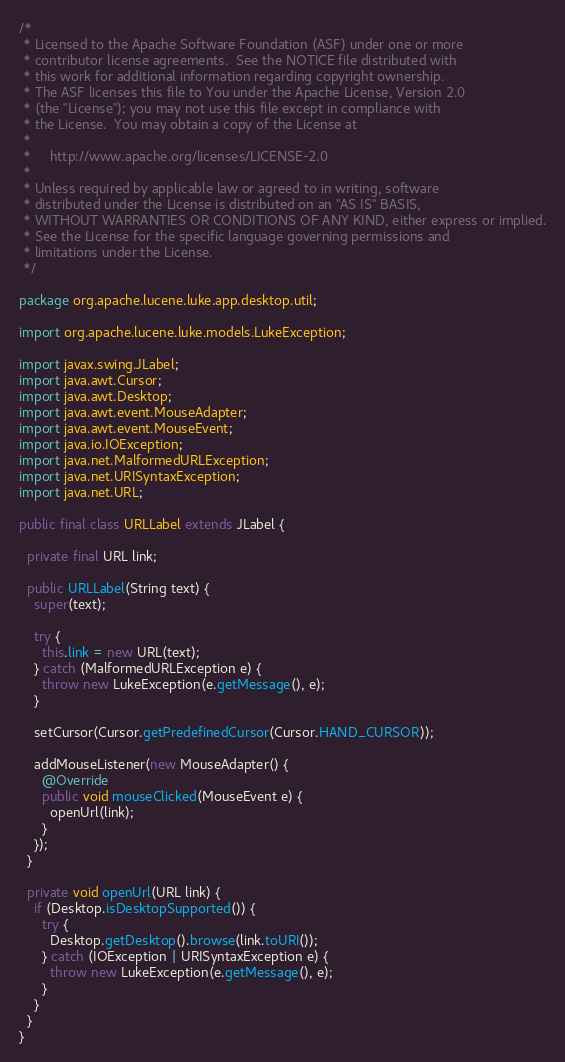<code> <loc_0><loc_0><loc_500><loc_500><_Java_>/*
 * Licensed to the Apache Software Foundation (ASF) under one or more
 * contributor license agreements.  See the NOTICE file distributed with
 * this work for additional information regarding copyright ownership.
 * The ASF licenses this file to You under the Apache License, Version 2.0
 * (the "License"); you may not use this file except in compliance with
 * the License.  You may obtain a copy of the License at
 *
 *     http://www.apache.org/licenses/LICENSE-2.0
 *
 * Unless required by applicable law or agreed to in writing, software
 * distributed under the License is distributed on an "AS IS" BASIS,
 * WITHOUT WARRANTIES OR CONDITIONS OF ANY KIND, either express or implied.
 * See the License for the specific language governing permissions and
 * limitations under the License.
 */

package org.apache.lucene.luke.app.desktop.util;

import org.apache.lucene.luke.models.LukeException;

import javax.swing.JLabel;
import java.awt.Cursor;
import java.awt.Desktop;
import java.awt.event.MouseAdapter;
import java.awt.event.MouseEvent;
import java.io.IOException;
import java.net.MalformedURLException;
import java.net.URISyntaxException;
import java.net.URL;

public final class URLLabel extends JLabel {

  private final URL link;

  public URLLabel(String text) {
    super(text);

    try {
      this.link = new URL(text);
    } catch (MalformedURLException e) {
      throw new LukeException(e.getMessage(), e);
    }

    setCursor(Cursor.getPredefinedCursor(Cursor.HAND_CURSOR));

    addMouseListener(new MouseAdapter() {
      @Override
      public void mouseClicked(MouseEvent e) {
        openUrl(link);
      }
    });
  }

  private void openUrl(URL link) {
    if (Desktop.isDesktopSupported()) {
      try {
        Desktop.getDesktop().browse(link.toURI());
      } catch (IOException | URISyntaxException e) {
        throw new LukeException(e.getMessage(), e);
      }
    }
  }
}
</code> 